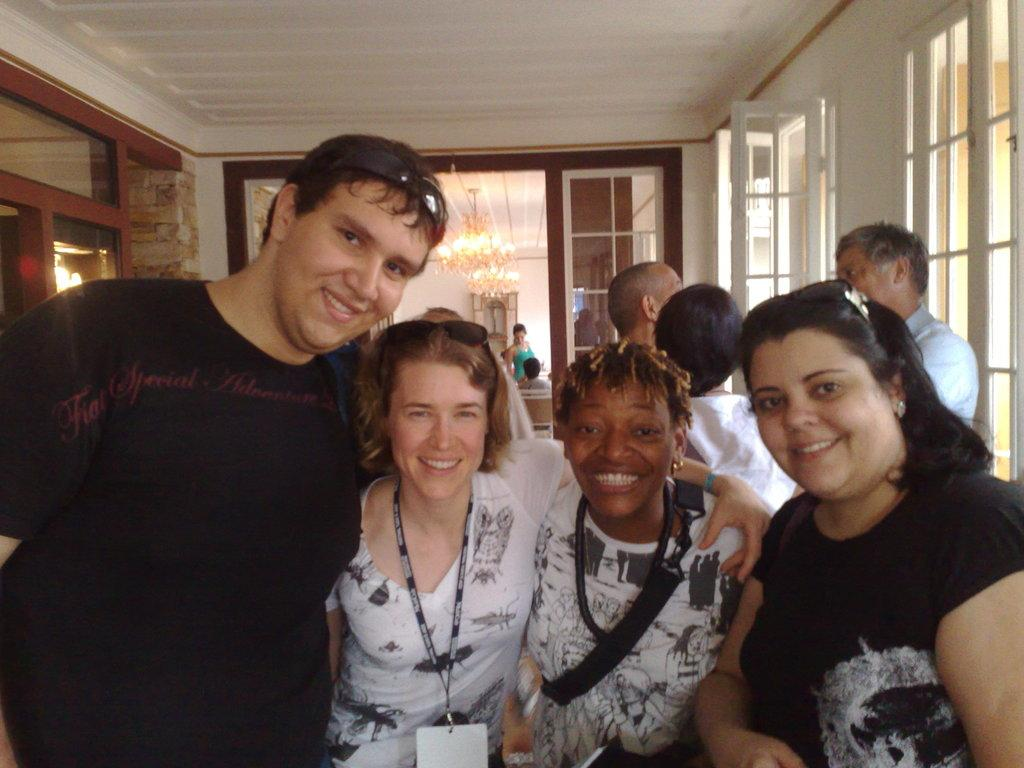Who or what is present in the image? There are people in the image. What is the facial expression of the people in the image? The people in the image are smiling. What architectural features can be seen in the image? There are windows in the image. What can be seen in the background of the image? In the background, there are people, chandeliers, a wall, chairs, and lights. What type of collar can be seen on the books in the image? There are no books or collars present in the image. Are the people in the image sleeping or resting? The people in the image are smiling, which suggests they are not sleeping or resting. 